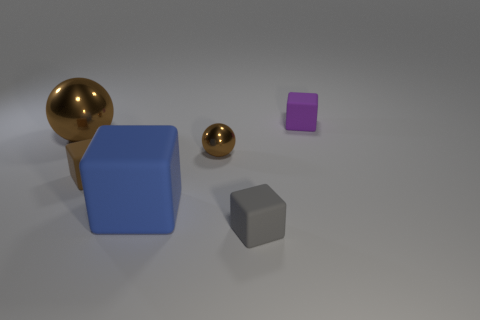Subtract all green blocks. Subtract all brown cylinders. How many blocks are left? 4 Add 4 small purple matte things. How many objects exist? 10 Subtract all cubes. How many objects are left? 2 Add 1 big blue things. How many big blue things exist? 2 Subtract 1 blue blocks. How many objects are left? 5 Subtract all yellow matte balls. Subtract all brown things. How many objects are left? 3 Add 3 tiny brown objects. How many tiny brown objects are left? 5 